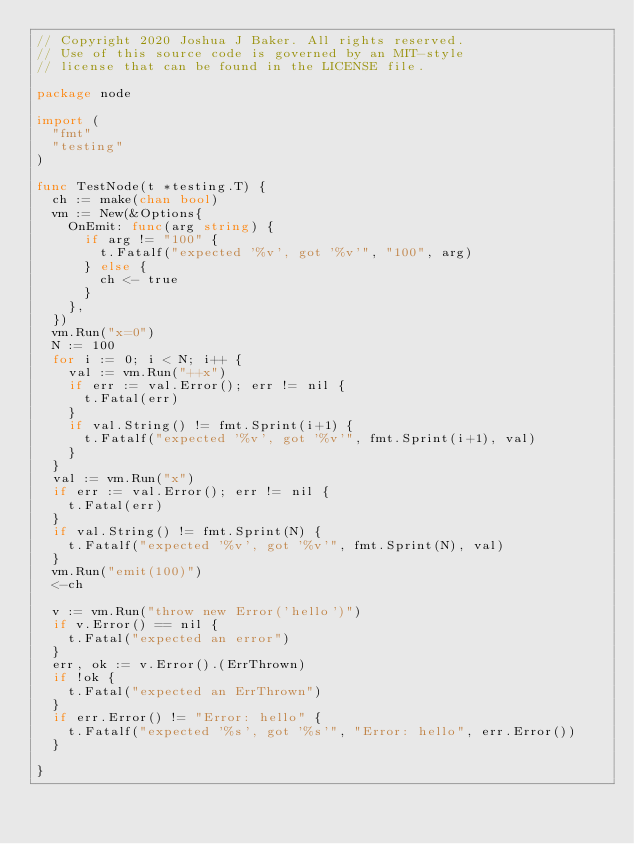Convert code to text. <code><loc_0><loc_0><loc_500><loc_500><_Go_>// Copyright 2020 Joshua J Baker. All rights reserved.
// Use of this source code is governed by an MIT-style
// license that can be found in the LICENSE file.

package node

import (
	"fmt"
	"testing"
)

func TestNode(t *testing.T) {
	ch := make(chan bool)
	vm := New(&Options{
		OnEmit: func(arg string) {
			if arg != "100" {
				t.Fatalf("expected '%v', got '%v'", "100", arg)
			} else {
				ch <- true
			}
		},
	})
	vm.Run("x=0")
	N := 100
	for i := 0; i < N; i++ {
		val := vm.Run("++x")
		if err := val.Error(); err != nil {
			t.Fatal(err)
		}
		if val.String() != fmt.Sprint(i+1) {
			t.Fatalf("expected '%v', got '%v'", fmt.Sprint(i+1), val)
		}
	}
	val := vm.Run("x")
	if err := val.Error(); err != nil {
		t.Fatal(err)
	}
	if val.String() != fmt.Sprint(N) {
		t.Fatalf("expected '%v', got '%v'", fmt.Sprint(N), val)
	}
	vm.Run("emit(100)")
	<-ch

	v := vm.Run("throw new Error('hello')")
	if v.Error() == nil {
		t.Fatal("expected an error")
	}
	err, ok := v.Error().(ErrThrown)
	if !ok {
		t.Fatal("expected an ErrThrown")
	}
	if err.Error() != "Error: hello" {
		t.Fatalf("expected '%s', got '%s'", "Error: hello", err.Error())
	}

}
</code> 